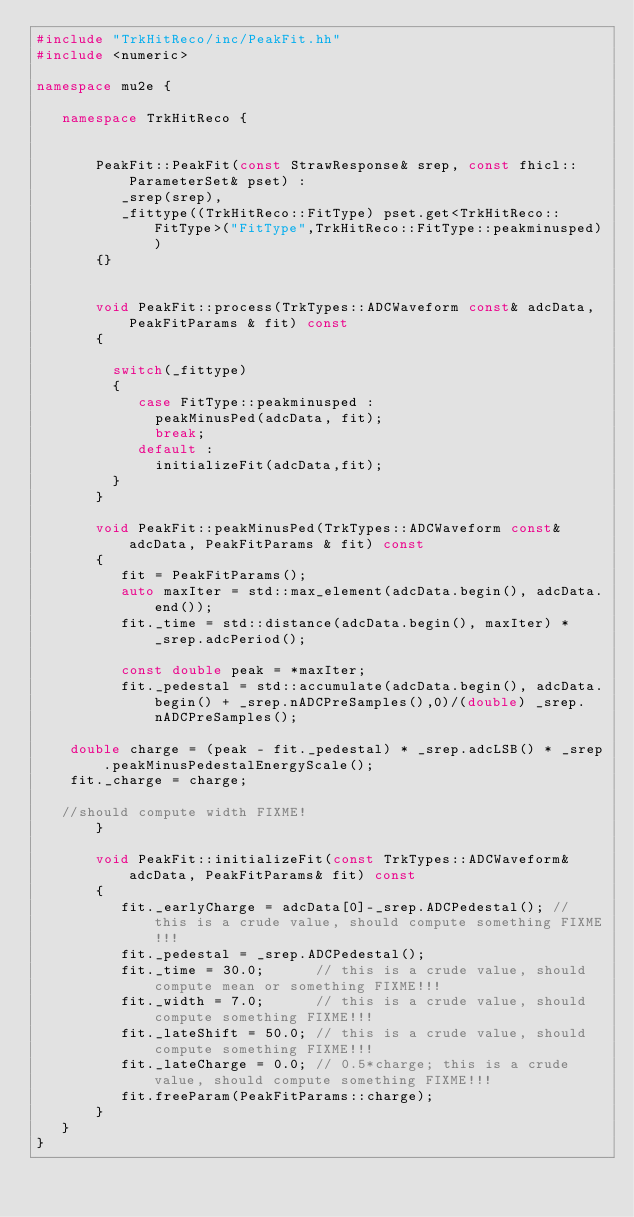Convert code to text. <code><loc_0><loc_0><loc_500><loc_500><_C++_>#include "TrkHitReco/inc/PeakFit.hh"
#include <numeric>

namespace mu2e {

   namespace TrkHitReco {


       PeakFit::PeakFit(const StrawResponse& srep, const fhicl::ParameterSet& pset) : 
          _srep(srep),
          _fittype((TrkHitReco::FitType) pset.get<TrkHitReco::FitType>("FitType",TrkHitReco::FitType::peakminusped))
       {}


       void PeakFit::process(TrkTypes::ADCWaveform const& adcData, PeakFitParams & fit) const
       {
         
         switch(_fittype)
         {
            case FitType::peakminusped :
              peakMinusPed(adcData, fit);
              break;
            default :
              initializeFit(adcData,fit);
         }
       }

       void PeakFit::peakMinusPed(TrkTypes::ADCWaveform const& adcData, PeakFitParams & fit) const
       {
          fit = PeakFitParams();
          auto maxIter = std::max_element(adcData.begin(), adcData.end());
          fit._time = std::distance(adcData.begin(), maxIter) * _srep.adcPeriod();

          const double peak = *maxIter;
          fit._pedestal = std::accumulate(adcData.begin(), adcData.begin() + _srep.nADCPreSamples(),0)/(double) _srep.nADCPreSamples();

	  double charge = (peak - fit._pedestal) * _srep.adcLSB() * _srep.peakMinusPedestalEnergyScale();
	  fit._charge = charge;

	 //should compute width FIXME!
       }

       void PeakFit::initializeFit(const TrkTypes::ADCWaveform& adcData, PeakFitParams& fit) const
       {
          fit._earlyCharge = adcData[0]-_srep.ADCPedestal(); // this is a crude value, should compute something FIXME!!!
          fit._pedestal = _srep.ADCPedestal();
          fit._time = 30.0;      // this is a crude value, should compute mean or something FIXME!!!
          fit._width = 7.0;      // this is a crude value, should compute something FIXME!!!
          fit._lateShift = 50.0; // this is a crude value, should compute something FIXME!!!
          fit._lateCharge = 0.0; // 0.5*charge; this is a crude value, should compute something FIXME!!!
          fit.freeParam(PeakFitParams::charge);
       }
   }
}
</code> 